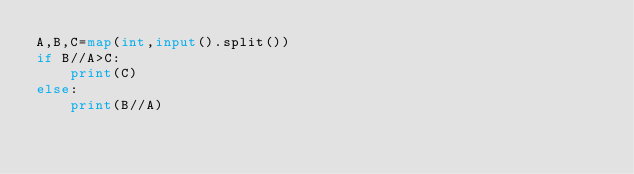<code> <loc_0><loc_0><loc_500><loc_500><_Python_>A,B,C=map(int,input().split())
if B//A>C:
    print(C)
else:
    print(B//A)</code> 